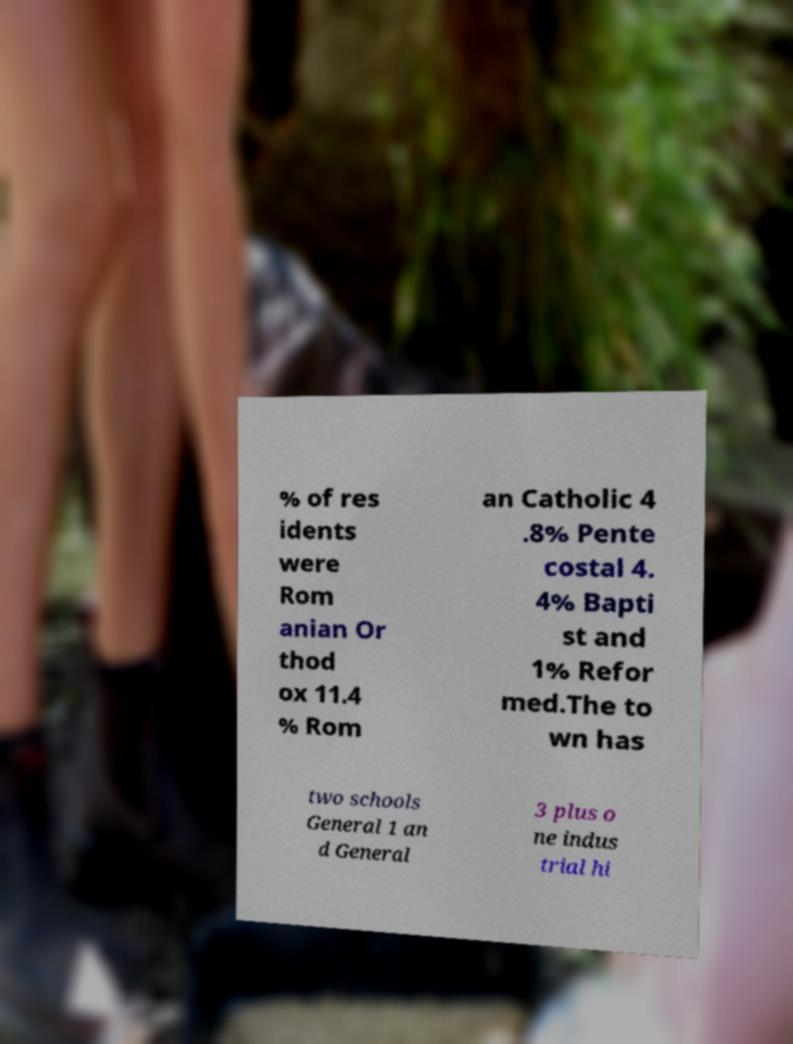Could you assist in decoding the text presented in this image and type it out clearly? % of res idents were Rom anian Or thod ox 11.4 % Rom an Catholic 4 .8% Pente costal 4. 4% Bapti st and 1% Refor med.The to wn has two schools General 1 an d General 3 plus o ne indus trial hi 